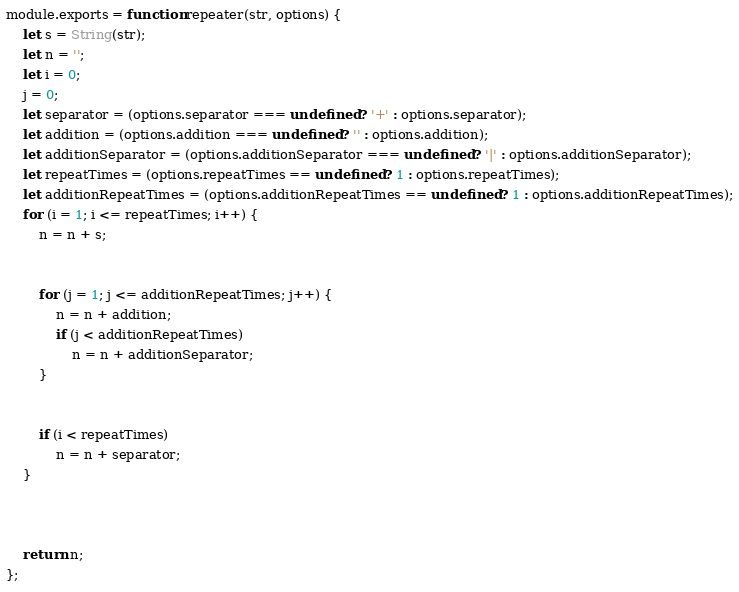Convert code to text. <code><loc_0><loc_0><loc_500><loc_500><_JavaScript_>module.exports = function repeater(str, options) {
    let s = String(str);
    let n = '';
    let i = 0;
    j = 0;
    let separator = (options.separator === undefined ? '+' : options.separator);
    let addition = (options.addition === undefined ? '' : options.addition);
    let additionSeparator = (options.additionSeparator === undefined ? '|' : options.additionSeparator);
    let repeatTimes = (options.repeatTimes == undefined ? 1 : options.repeatTimes);
    let additionRepeatTimes = (options.additionRepeatTimes == undefined ? 1 : options.additionRepeatTimes);
    for (i = 1; i <= repeatTimes; i++) {
        n = n + s;


        for (j = 1; j <= additionRepeatTimes; j++) {
            n = n + addition;
            if (j < additionRepeatTimes)
                n = n + additionSeparator;
        }


        if (i < repeatTimes)
            n = n + separator;
    }



    return n;
};</code> 